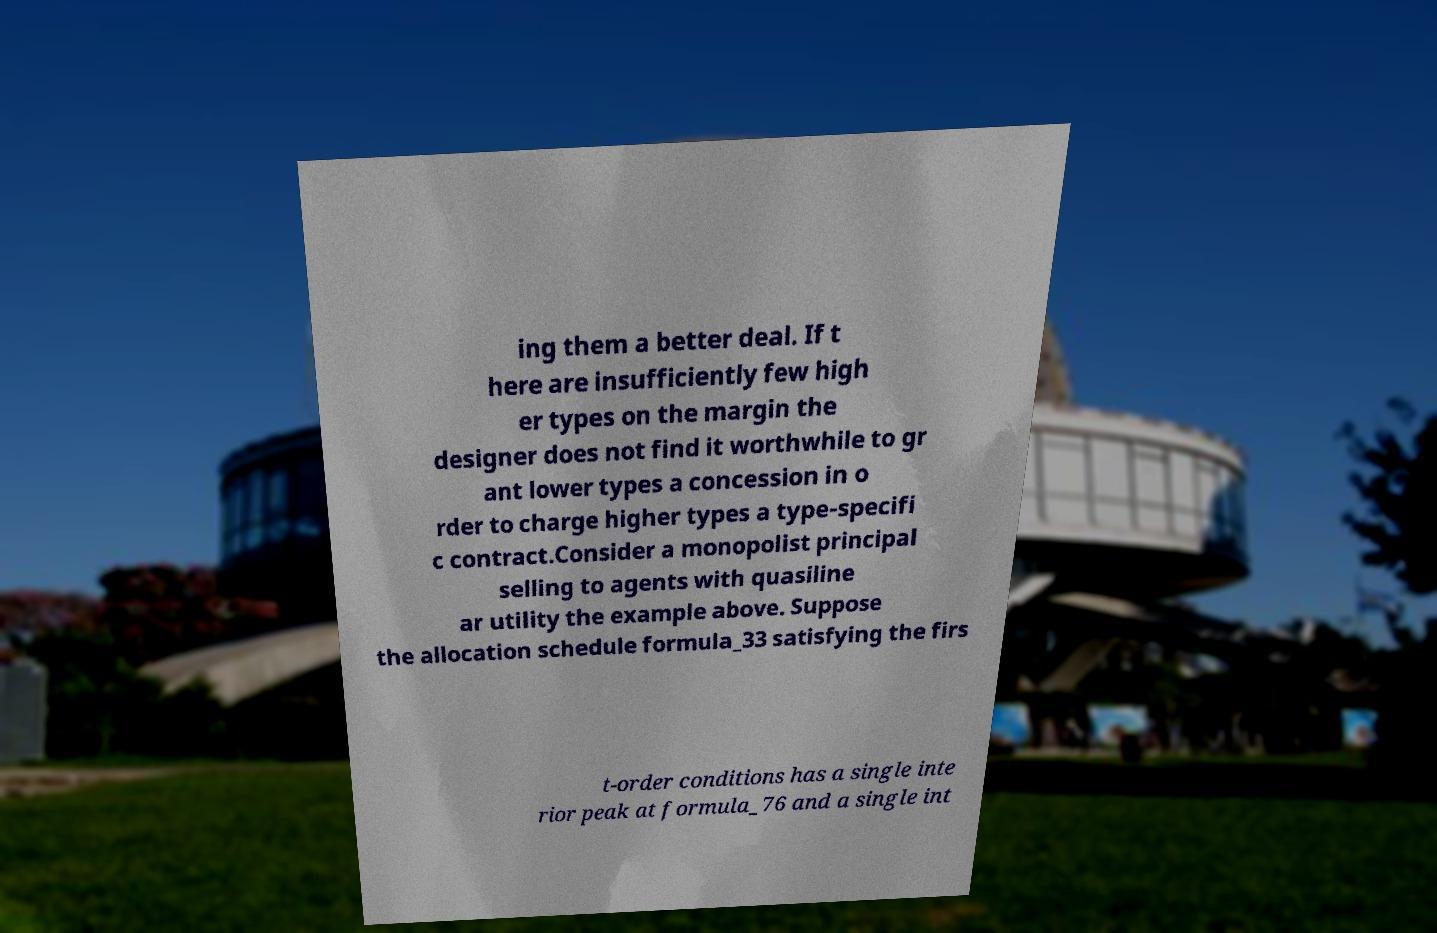Please identify and transcribe the text found in this image. ing them a better deal. If t here are insufficiently few high er types on the margin the designer does not find it worthwhile to gr ant lower types a concession in o rder to charge higher types a type-specifi c contract.Consider a monopolist principal selling to agents with quasiline ar utility the example above. Suppose the allocation schedule formula_33 satisfying the firs t-order conditions has a single inte rior peak at formula_76 and a single int 